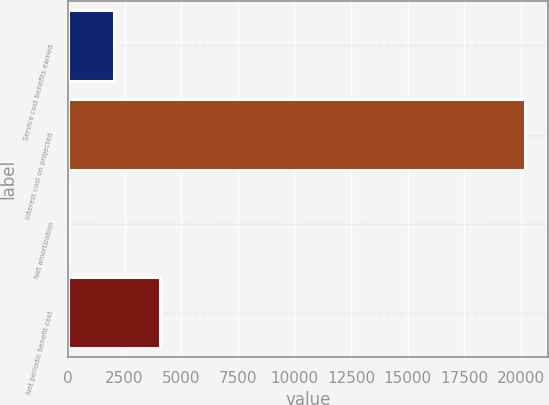Convert chart. <chart><loc_0><loc_0><loc_500><loc_500><bar_chart><fcel>Service cost benefits earned<fcel>Interest cost on projected<fcel>Net amortization<fcel>Net periodic benefit cost<nl><fcel>2045.9<fcel>20189<fcel>30<fcel>4061.8<nl></chart> 